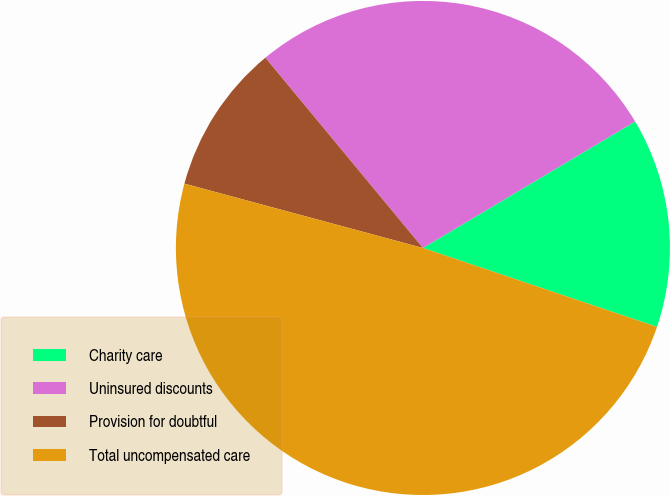Convert chart to OTSL. <chart><loc_0><loc_0><loc_500><loc_500><pie_chart><fcel>Charity care<fcel>Uninsured discounts<fcel>Provision for doubtful<fcel>Total uncompensated care<nl><fcel>13.73%<fcel>27.45%<fcel>9.8%<fcel>49.02%<nl></chart> 